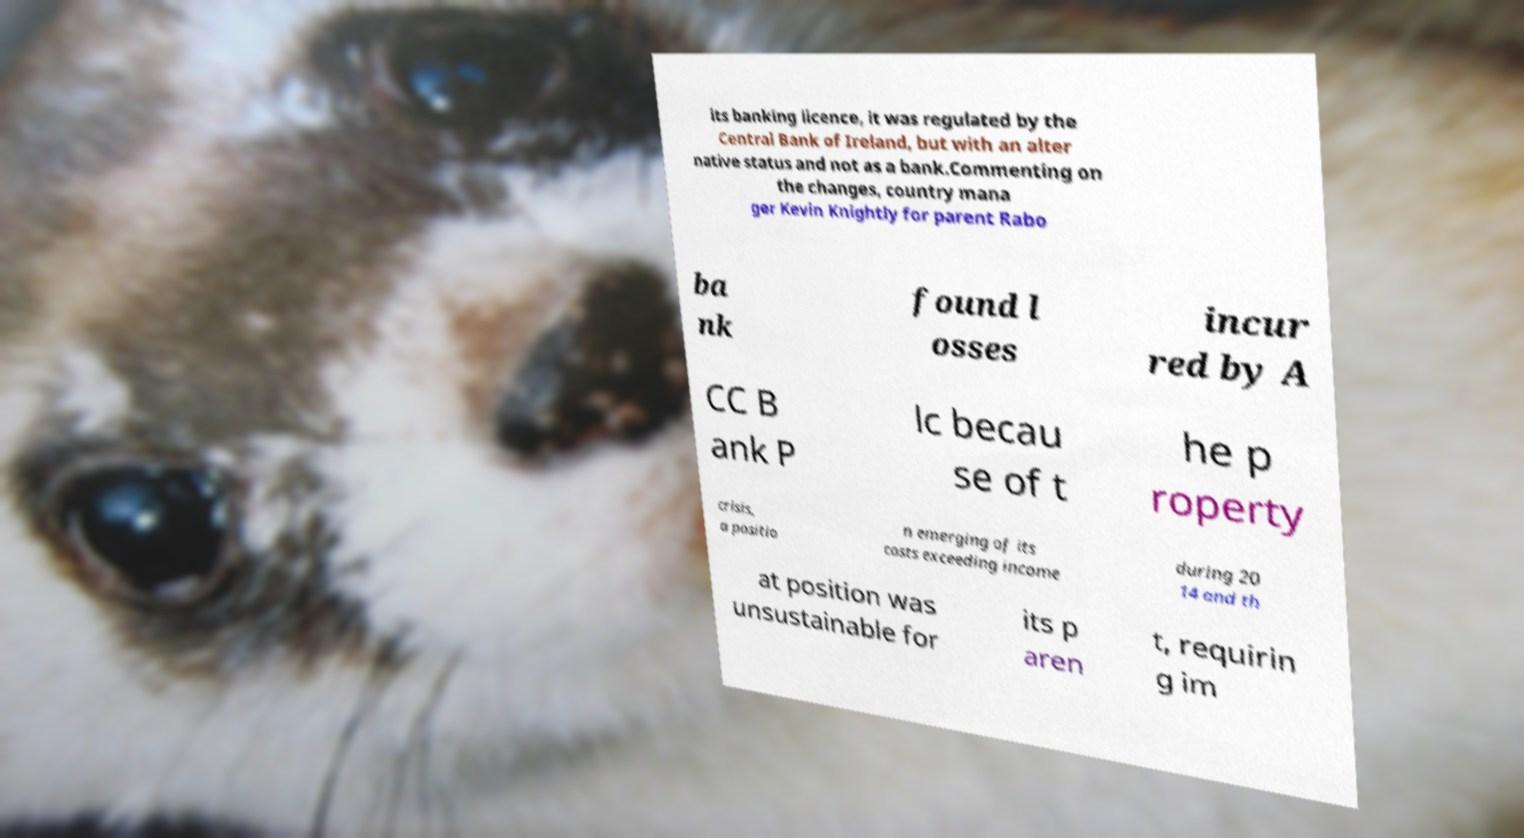Could you extract and type out the text from this image? its banking licence, it was regulated by the Central Bank of Ireland, but with an alter native status and not as a bank.Commenting on the changes, country mana ger Kevin Knightly for parent Rabo ba nk found l osses incur red by A CC B ank P lc becau se of t he p roperty crisis, a positio n emerging of its costs exceeding income during 20 14 and th at position was unsustainable for its p aren t, requirin g im 